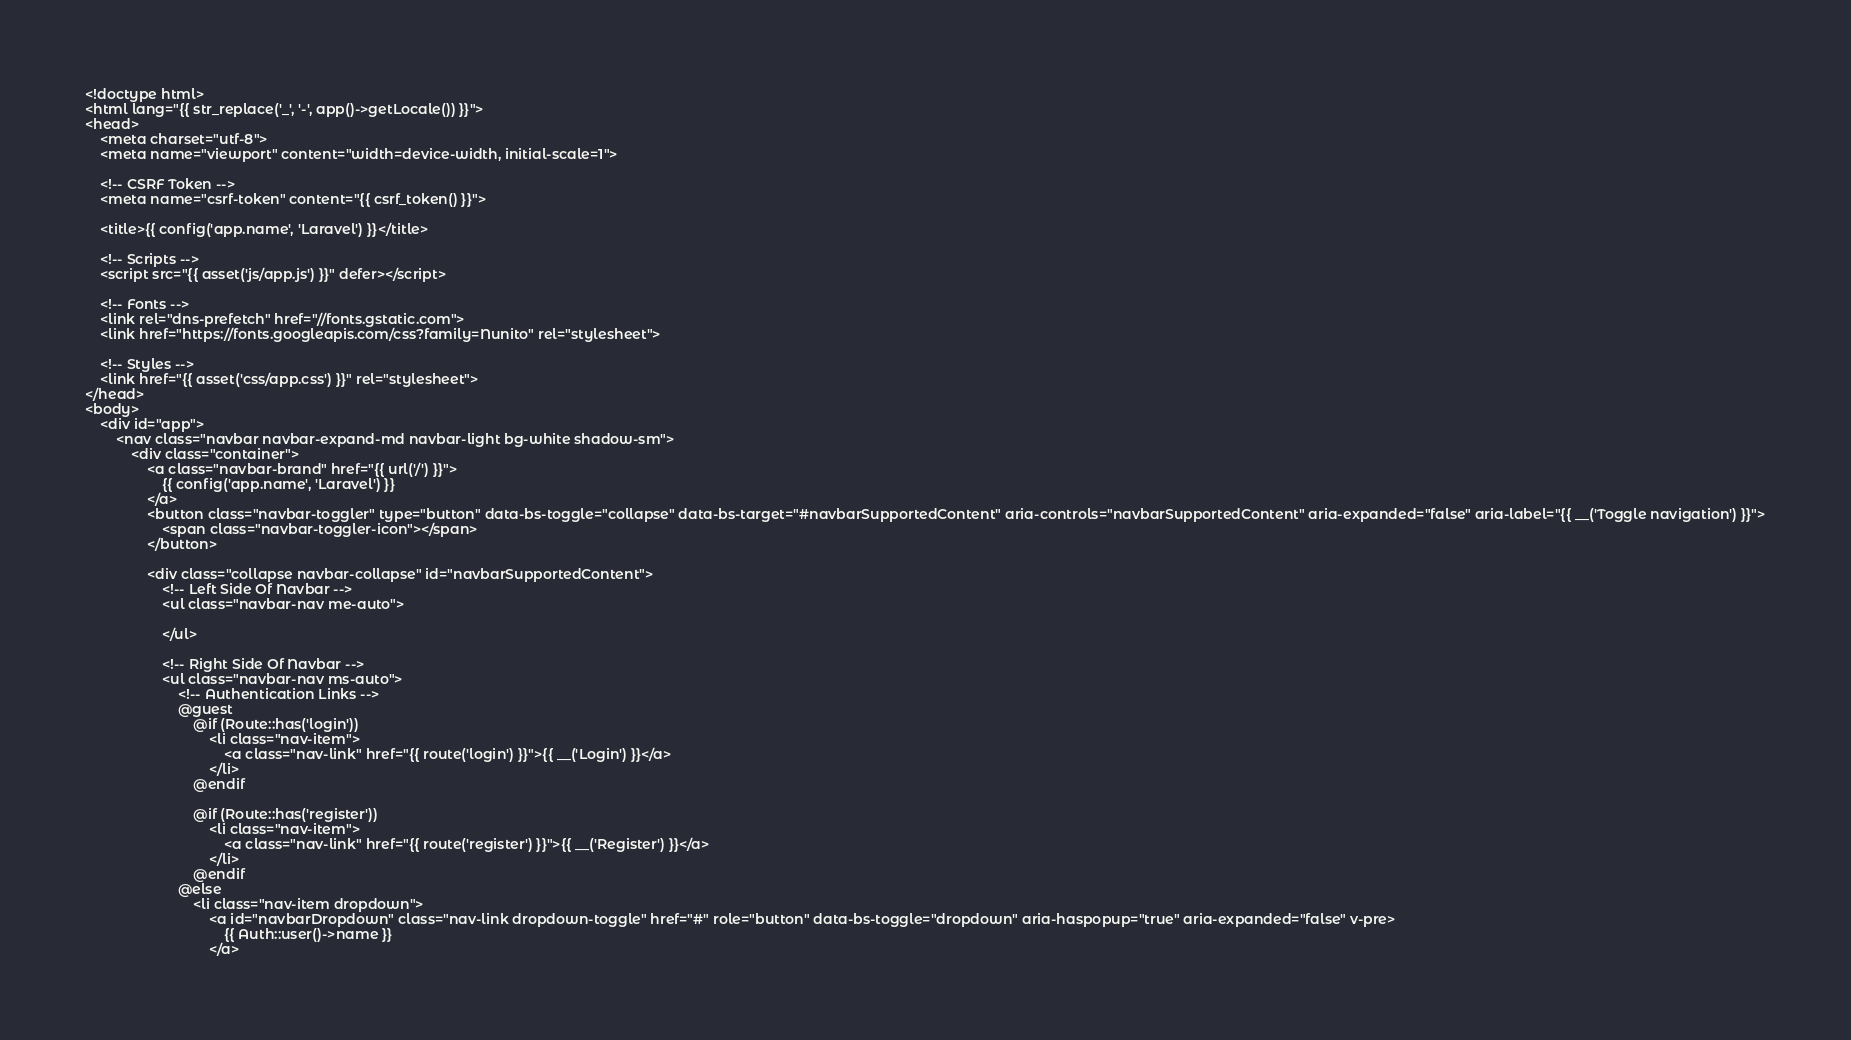Convert code to text. <code><loc_0><loc_0><loc_500><loc_500><_PHP_><!doctype html>
<html lang="{{ str_replace('_', '-', app()->getLocale()) }}">
<head>
    <meta charset="utf-8">
    <meta name="viewport" content="width=device-width, initial-scale=1">

    <!-- CSRF Token -->
    <meta name="csrf-token" content="{{ csrf_token() }}">

    <title>{{ config('app.name', 'Laravel') }}</title>

    <!-- Scripts -->
    <script src="{{ asset('js/app.js') }}" defer></script>

    <!-- Fonts -->
    <link rel="dns-prefetch" href="//fonts.gstatic.com">
    <link href="https://fonts.googleapis.com/css?family=Nunito" rel="stylesheet">

    <!-- Styles -->
    <link href="{{ asset('css/app.css') }}" rel="stylesheet">
</head>
<body>
    <div id="app">
        <nav class="navbar navbar-expand-md navbar-light bg-white shadow-sm">
            <div class="container">
                <a class="navbar-brand" href="{{ url('/') }}">
                    {{ config('app.name', 'Laravel') }}
                </a>
                <button class="navbar-toggler" type="button" data-bs-toggle="collapse" data-bs-target="#navbarSupportedContent" aria-controls="navbarSupportedContent" aria-expanded="false" aria-label="{{ __('Toggle navigation') }}">
                    <span class="navbar-toggler-icon"></span>
                </button>

                <div class="collapse navbar-collapse" id="navbarSupportedContent">
                    <!-- Left Side Of Navbar -->
                    <ul class="navbar-nav me-auto">

                    </ul>

                    <!-- Right Side Of Navbar -->
                    <ul class="navbar-nav ms-auto">
                        <!-- Authentication Links -->
                        @guest
                            @if (Route::has('login'))
                                <li class="nav-item">
                                    <a class="nav-link" href="{{ route('login') }}">{{ __('Login') }}</a>
                                </li>
                            @endif

                            @if (Route::has('register'))
                                <li class="nav-item">
                                    <a class="nav-link" href="{{ route('register') }}">{{ __('Register') }}</a>
                                </li>
                            @endif
                        @else
                            <li class="nav-item dropdown">
                                <a id="navbarDropdown" class="nav-link dropdown-toggle" href="#" role="button" data-bs-toggle="dropdown" aria-haspopup="true" aria-expanded="false" v-pre>
                                    {{ Auth::user()->name }}
                                </a>
</code> 